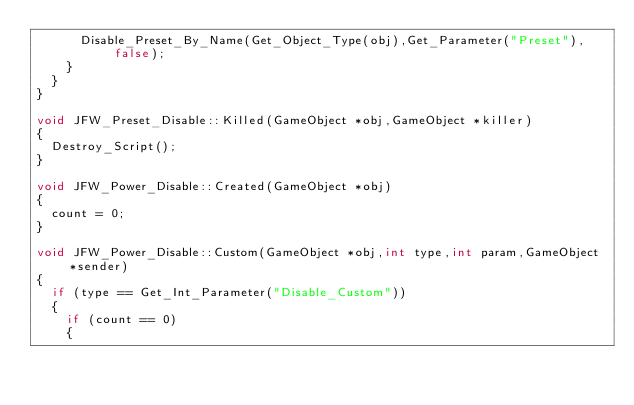<code> <loc_0><loc_0><loc_500><loc_500><_C++_>			Disable_Preset_By_Name(Get_Object_Type(obj),Get_Parameter("Preset"),false);
		}
	}
}

void JFW_Preset_Disable::Killed(GameObject *obj,GameObject *killer)
{
	Destroy_Script();
}

void JFW_Power_Disable::Created(GameObject *obj)
{
	count = 0;
}

void JFW_Power_Disable::Custom(GameObject *obj,int type,int param,GameObject *sender)
{
	if (type == Get_Int_Parameter("Disable_Custom"))
	{
		if (count == 0)
		{</code> 